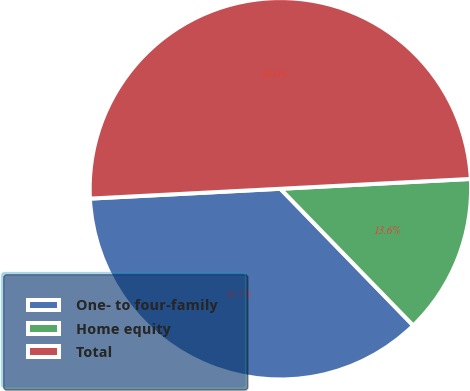<chart> <loc_0><loc_0><loc_500><loc_500><pie_chart><fcel>One- to four-family<fcel>Home equity<fcel>Total<nl><fcel>36.45%<fcel>13.55%<fcel>50.0%<nl></chart> 